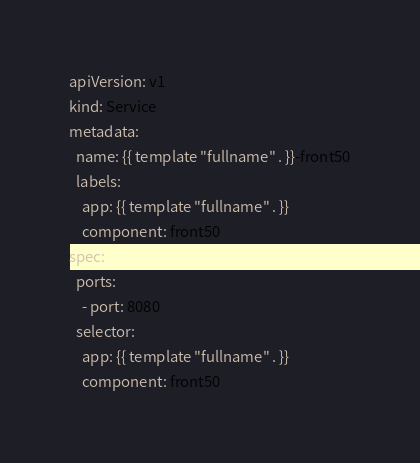<code> <loc_0><loc_0><loc_500><loc_500><_YAML_>apiVersion: v1
kind: Service
metadata:
  name: {{ template "fullname" . }}-front50
  labels:
    app: {{ template "fullname" . }}
    component: front50
spec:
  ports:
    - port: 8080
  selector:
    app: {{ template "fullname" . }}
    component: front50
</code> 